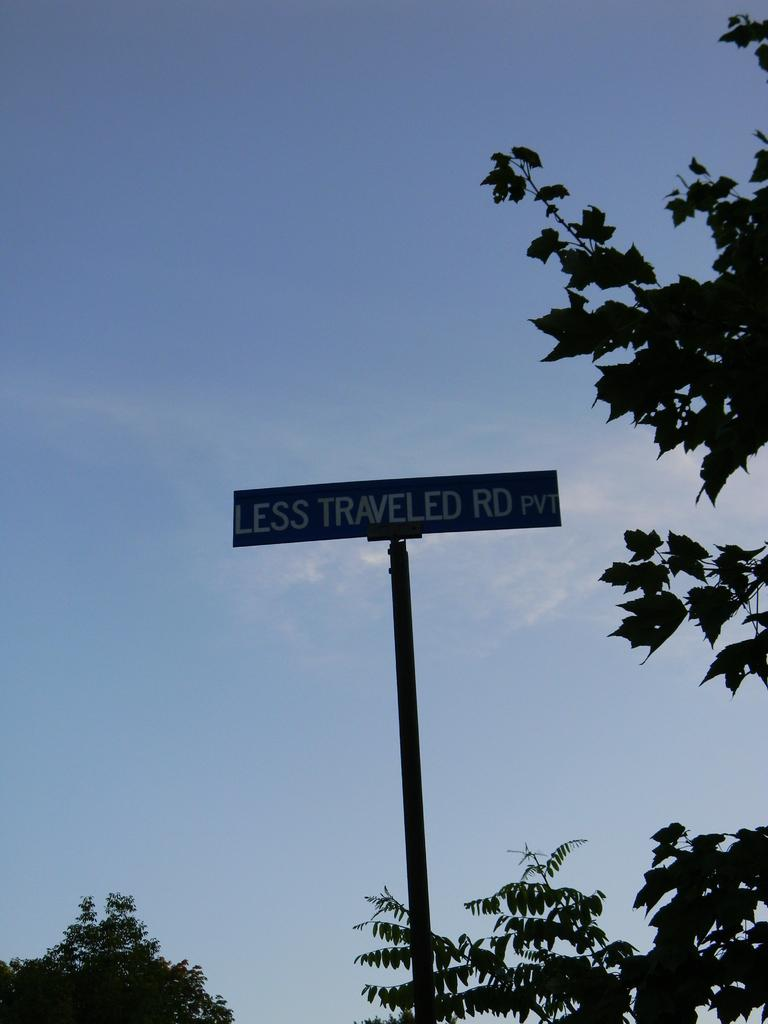What type of vegetation can be seen on the left side of the image? There are trees on the left side of the image. What type of vegetation can be seen on the right side of the image? There are trees on the right side of the image. What structure is located in the middle of the image? There is a name board pole in the middle of the image. What can be seen in the sky in the background of the image? There are clouds in the sky in the background of the image. What type of steel is used to construct the tub in the image? There is no tub present in the image, so the type of steel used for its construction cannot be determined. What is the limit of the trees' growth in the image? The facts provided do not give information about the trees' growth or any limits, so this cannot be answered definitively. 